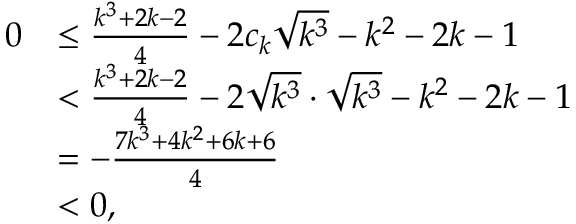Convert formula to latex. <formula><loc_0><loc_0><loc_500><loc_500>\begin{array} { r l } { 0 } & { \leq \frac { k ^ { 3 } + 2 k - 2 } { 4 } - 2 c _ { k } \sqrt { k ^ { 3 } } - k ^ { 2 } - 2 k - 1 } \\ & { < \frac { k ^ { 3 } + 2 k - 2 } { 4 } - 2 \sqrt { k ^ { 3 } } \cdot \sqrt { k ^ { 3 } } - k ^ { 2 } - 2 k - 1 } \\ & { = - \frac { 7 k ^ { 3 } + 4 k ^ { 2 } + 6 k + 6 } { 4 } } \\ & { < 0 , } \end{array}</formula> 